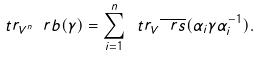Convert formula to latex. <formula><loc_0><loc_0><loc_500><loc_500>\ t r _ { V ^ { n } } \ r b ( \gamma ) = \sum _ { i = 1 } ^ { n } \ t r _ { V } \overline { \ r s } ( \alpha _ { i } \gamma \alpha _ { i } ^ { - 1 } ) .</formula> 